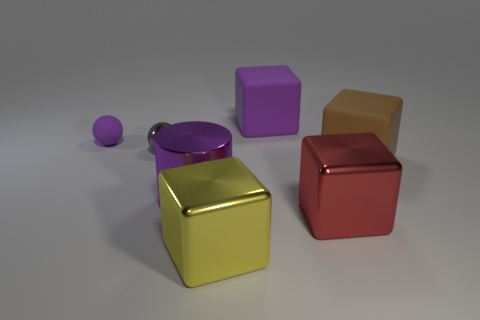What material is the block that is both behind the big purple metal object and in front of the tiny purple ball?
Provide a succinct answer. Rubber. There is a large thing behind the brown cube; what number of big red objects are to the left of it?
Keep it short and to the point. 0. There is a big brown matte thing; what shape is it?
Your answer should be compact. Cube. There is a large thing that is made of the same material as the big brown block; what shape is it?
Your answer should be compact. Cube. Does the purple object that is on the left side of the purple cylinder have the same shape as the tiny gray shiny object?
Offer a very short reply. Yes. There is a large metallic thing behind the big red cube; what is its shape?
Offer a terse response. Cylinder. What shape is the large rubber object that is the same color as the cylinder?
Make the answer very short. Cube. What number of gray spheres have the same size as the brown cube?
Your answer should be very brief. 0. What is the color of the small metal ball?
Keep it short and to the point. Gray. There is a cylinder; is its color the same as the matte object to the left of the purple shiny cylinder?
Ensure brevity in your answer.  Yes. 